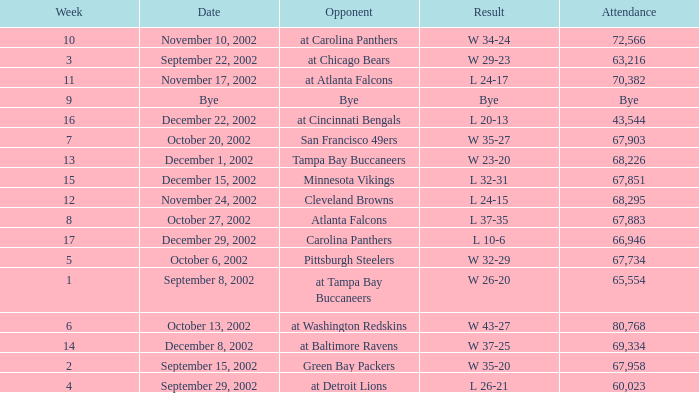Who was the opposing team in the game attended by 65,554? At tampa bay buccaneers. 